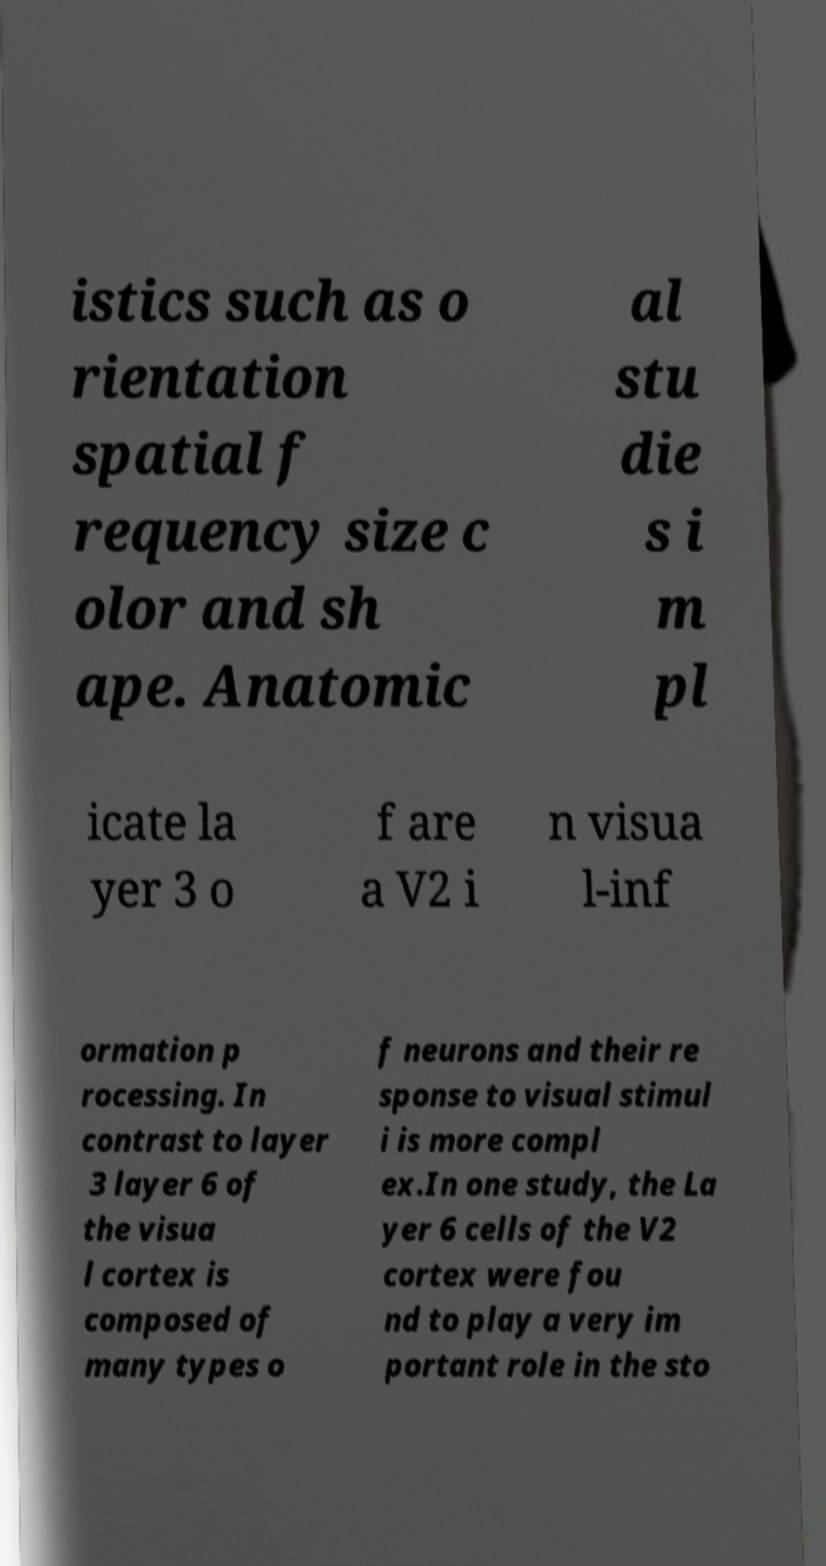Can you read and provide the text displayed in the image?This photo seems to have some interesting text. Can you extract and type it out for me? istics such as o rientation spatial f requency size c olor and sh ape. Anatomic al stu die s i m pl icate la yer 3 o f are a V2 i n visua l-inf ormation p rocessing. In contrast to layer 3 layer 6 of the visua l cortex is composed of many types o f neurons and their re sponse to visual stimul i is more compl ex.In one study, the La yer 6 cells of the V2 cortex were fou nd to play a very im portant role in the sto 